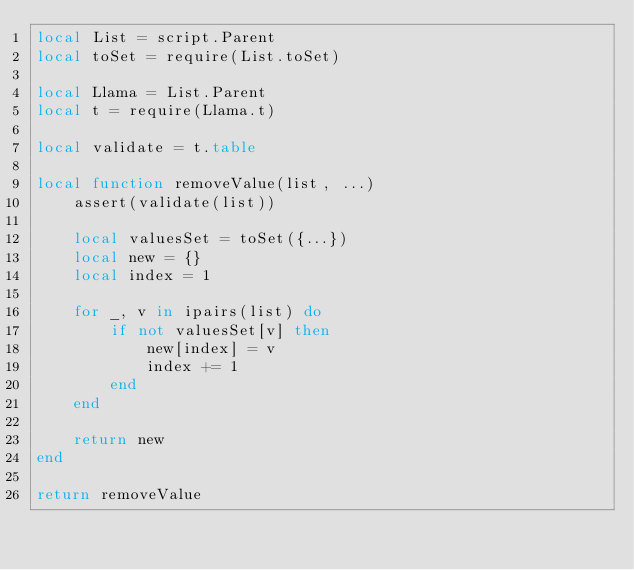Convert code to text. <code><loc_0><loc_0><loc_500><loc_500><_Lua_>local List = script.Parent
local toSet = require(List.toSet)

local Llama = List.Parent
local t = require(Llama.t)

local validate = t.table

local function removeValue(list, ...)
	assert(validate(list))

	local valuesSet = toSet({...})
	local new = {}
	local index = 1

	for _, v in ipairs(list) do
		if not valuesSet[v] then
			new[index] = v
			index += 1
		end
	end

	return new
end

return removeValue</code> 